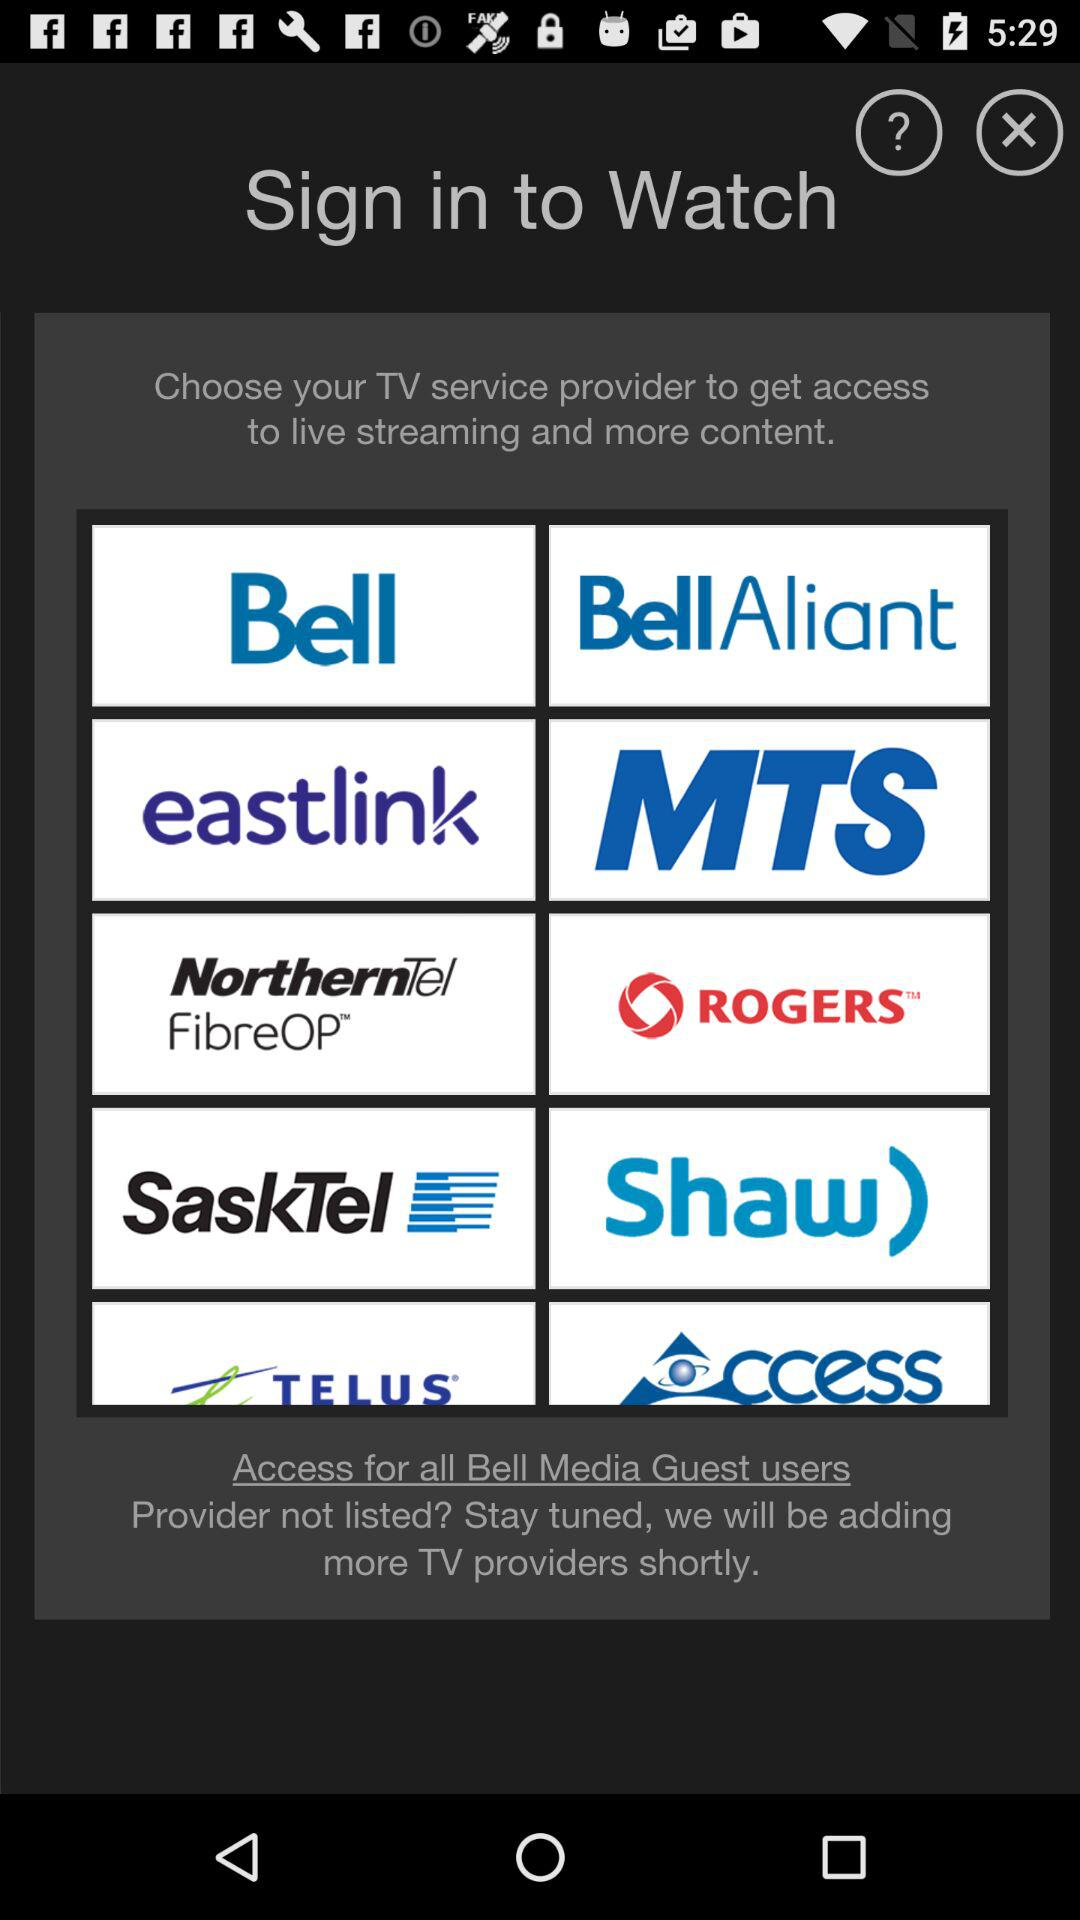Which are the different TV service providers? The different TV service providers are "Bell", "BellAliant", "eastlink", "MTS", "NorthernTel FibreOP", "ROGERS", "SaskTel", "Shaw", "TELUS" and "Access". 